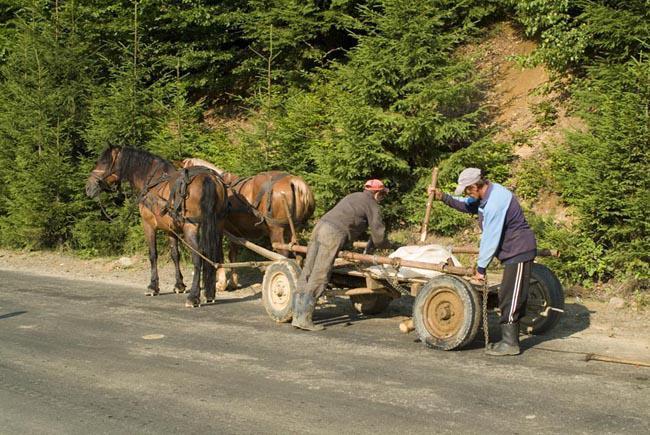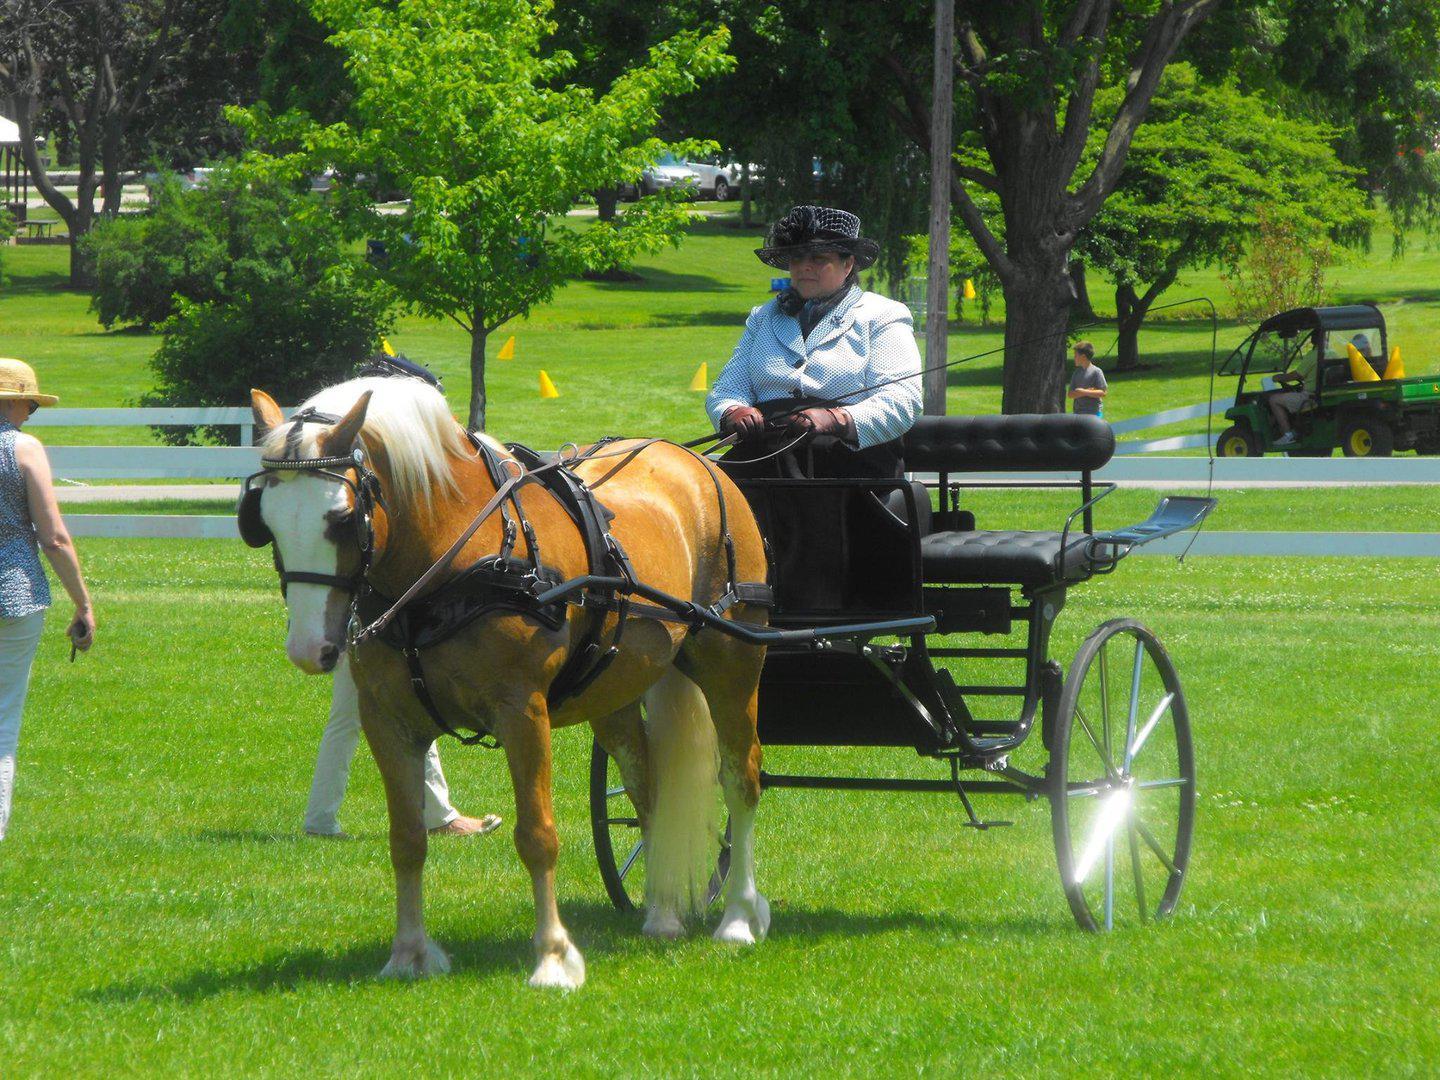The first image is the image on the left, the second image is the image on the right. Evaluate the accuracy of this statement regarding the images: "One image shows a leftward-facing pony with a white mane hitched to a two-wheeled cart carrying one woman in a hat.". Is it true? Answer yes or no. Yes. The first image is the image on the left, the second image is the image on the right. For the images shown, is this caption "Horses are transporting people in both images." true? Answer yes or no. No. 